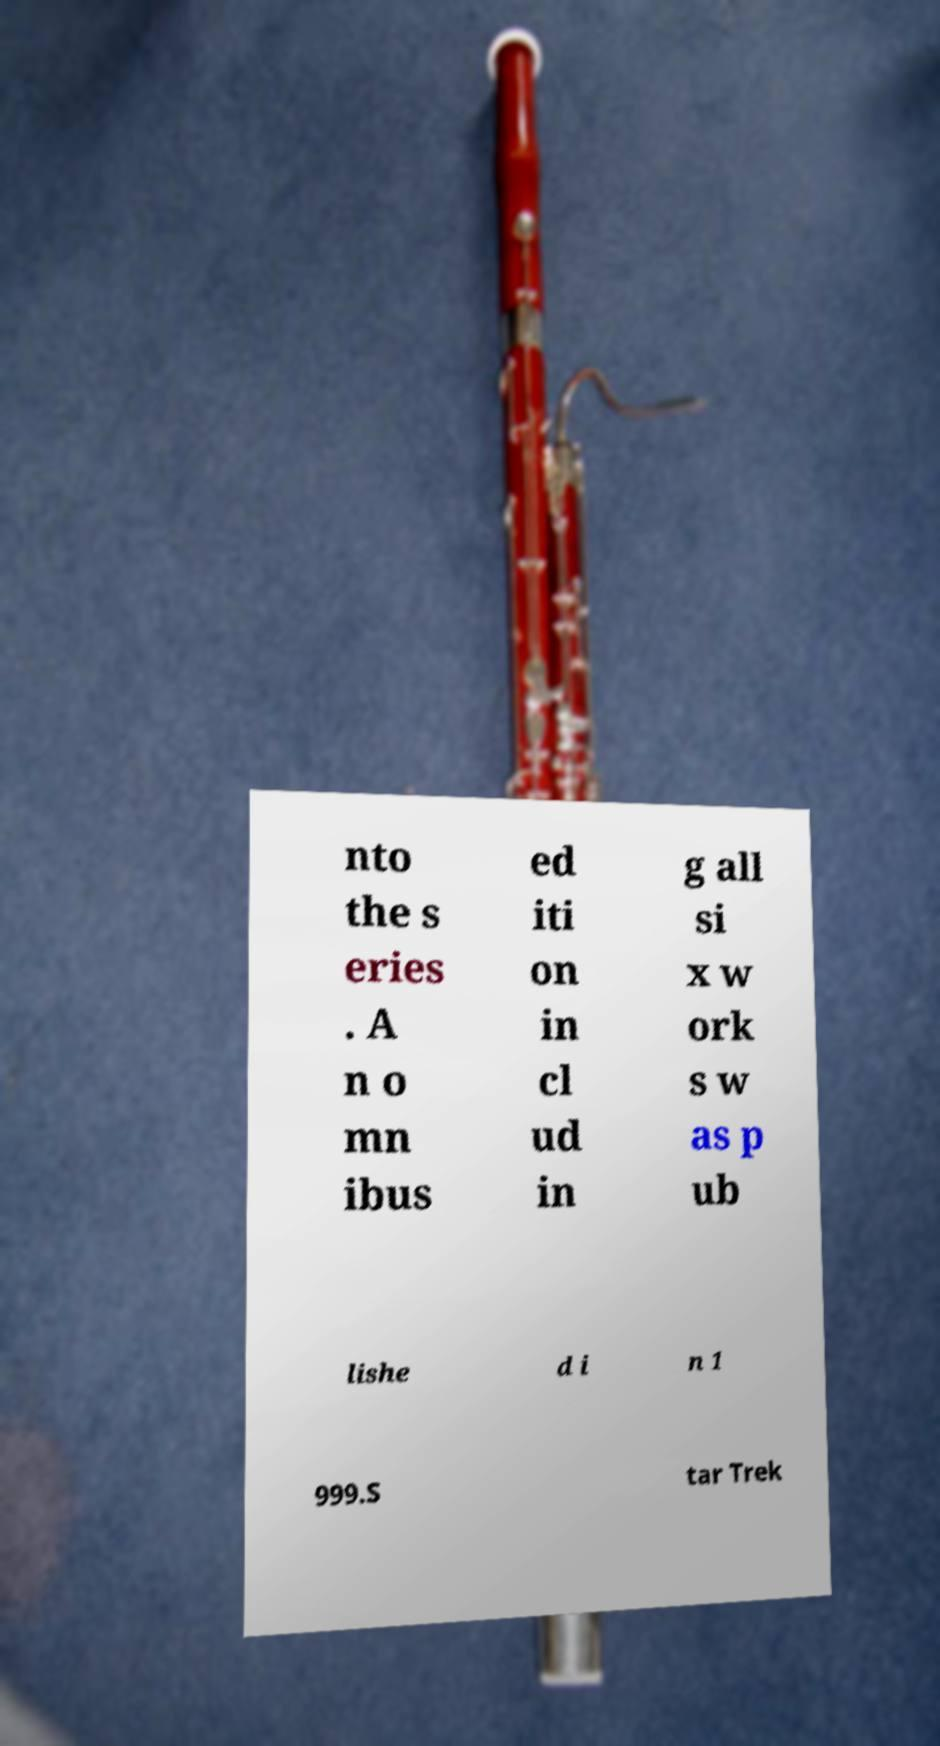Please identify and transcribe the text found in this image. nto the s eries . A n o mn ibus ed iti on in cl ud in g all si x w ork s w as p ub lishe d i n 1 999.S tar Trek 